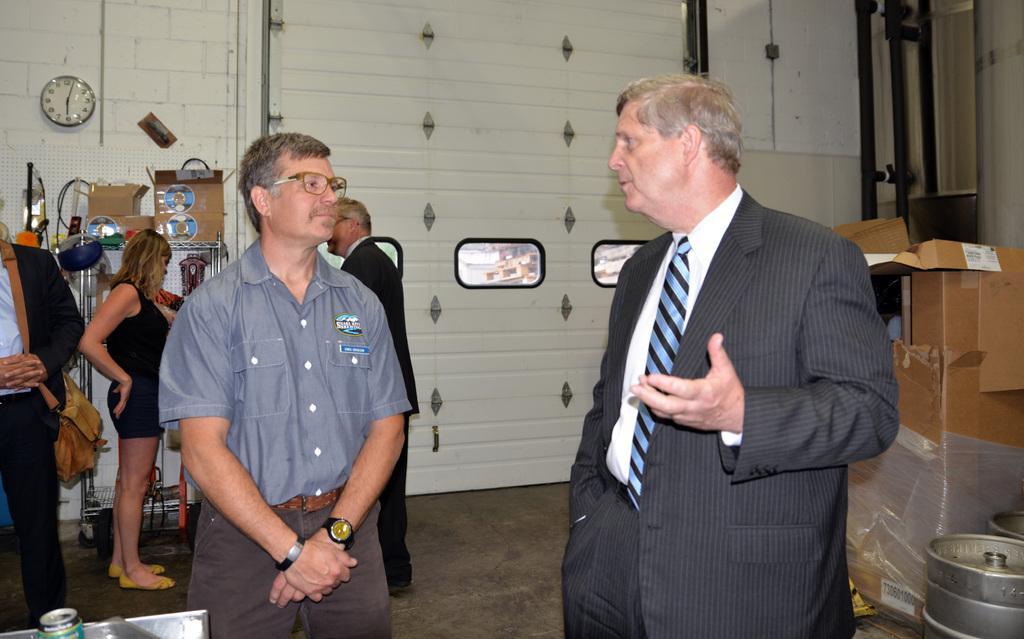Describe this image in one or two sentences. In this image in the center there are two persons who are standing, and in the background there are some people. On the right side there are some boxes and some vessels. In the background there is a wall, on the wall there is one clock and some pipes. On the left side there are some boxes, poles, wires and some other objects. At the bottom there is a floor. 